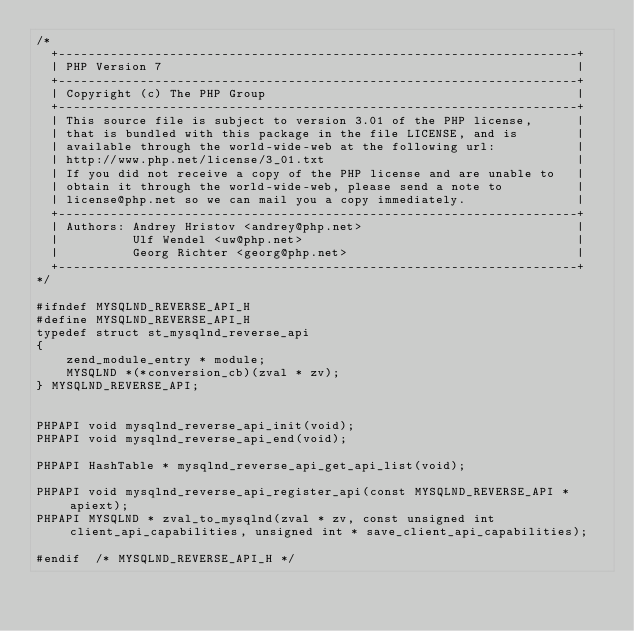<code> <loc_0><loc_0><loc_500><loc_500><_C_>/*
  +----------------------------------------------------------------------+
  | PHP Version 7                                                        |
  +----------------------------------------------------------------------+
  | Copyright (c) The PHP Group                                          |
  +----------------------------------------------------------------------+
  | This source file is subject to version 3.01 of the PHP license,      |
  | that is bundled with this package in the file LICENSE, and is        |
  | available through the world-wide-web at the following url:           |
  | http://www.php.net/license/3_01.txt                                  |
  | If you did not receive a copy of the PHP license and are unable to   |
  | obtain it through the world-wide-web, please send a note to          |
  | license@php.net so we can mail you a copy immediately.               |
  +----------------------------------------------------------------------+
  | Authors: Andrey Hristov <andrey@php.net>                             |
  |          Ulf Wendel <uw@php.net>                                     |
  |          Georg Richter <georg@php.net>                               |
  +----------------------------------------------------------------------+
*/

#ifndef MYSQLND_REVERSE_API_H
#define MYSQLND_REVERSE_API_H
typedef struct st_mysqlnd_reverse_api
{
	zend_module_entry * module;
	MYSQLND *(*conversion_cb)(zval * zv);
} MYSQLND_REVERSE_API;


PHPAPI void mysqlnd_reverse_api_init(void);
PHPAPI void mysqlnd_reverse_api_end(void);

PHPAPI HashTable * mysqlnd_reverse_api_get_api_list(void);

PHPAPI void mysqlnd_reverse_api_register_api(const MYSQLND_REVERSE_API * apiext);
PHPAPI MYSQLND * zval_to_mysqlnd(zval * zv, const unsigned int client_api_capabilities, unsigned int * save_client_api_capabilities);

#endif	/* MYSQLND_REVERSE_API_H */
</code> 